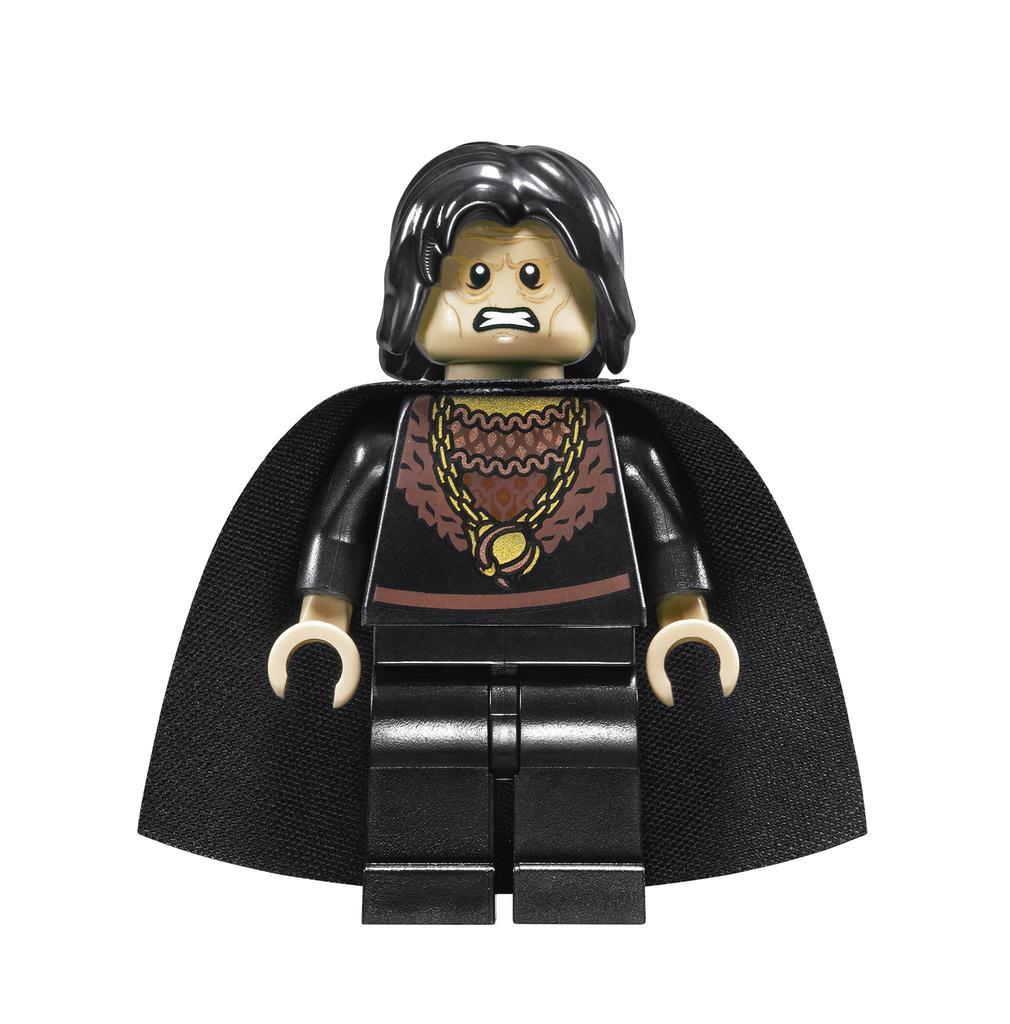Could you give a brief overview of what you see in this image? In this image I can a toy that is with black clothing and the background is white. 